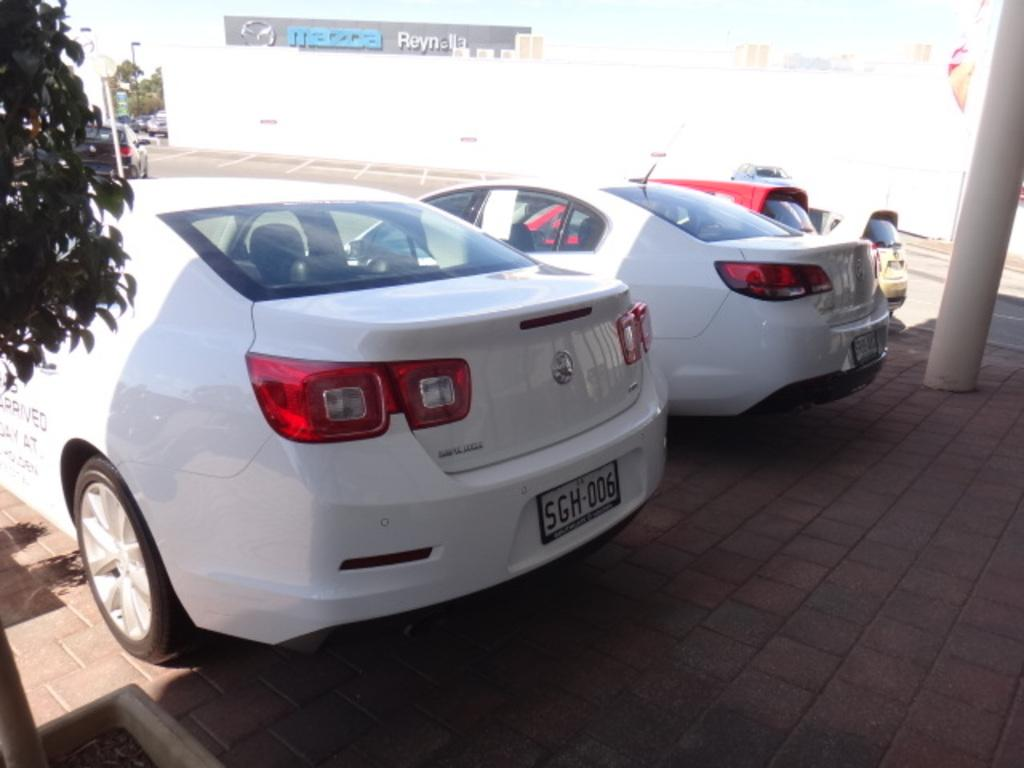<image>
Summarize the visual content of the image. A white parked car has the license plate 5GH-006. 